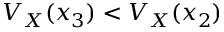<formula> <loc_0><loc_0><loc_500><loc_500>V _ { X } ( x _ { 3 } ) < V _ { X } ( x _ { 2 } )</formula> 